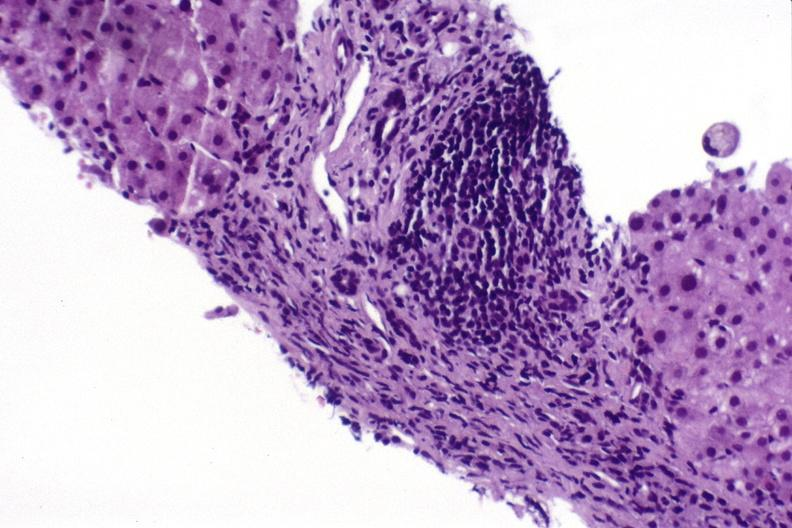what does this image show?
Answer the question using a single word or phrase. Hepatitis c virus 